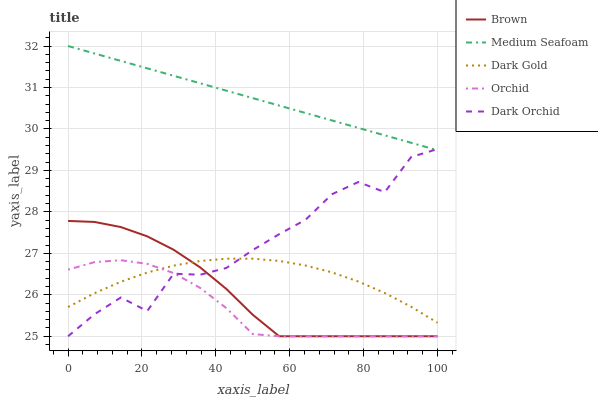Does Orchid have the minimum area under the curve?
Answer yes or no. Yes. Does Medium Seafoam have the maximum area under the curve?
Answer yes or no. Yes. Does Medium Seafoam have the minimum area under the curve?
Answer yes or no. No. Does Orchid have the maximum area under the curve?
Answer yes or no. No. Is Medium Seafoam the smoothest?
Answer yes or no. Yes. Is Dark Orchid the roughest?
Answer yes or no. Yes. Is Orchid the smoothest?
Answer yes or no. No. Is Orchid the roughest?
Answer yes or no. No. Does Brown have the lowest value?
Answer yes or no. Yes. Does Medium Seafoam have the lowest value?
Answer yes or no. No. Does Medium Seafoam have the highest value?
Answer yes or no. Yes. Does Orchid have the highest value?
Answer yes or no. No. Is Brown less than Medium Seafoam?
Answer yes or no. Yes. Is Medium Seafoam greater than Dark Gold?
Answer yes or no. Yes. Does Dark Orchid intersect Brown?
Answer yes or no. Yes. Is Dark Orchid less than Brown?
Answer yes or no. No. Is Dark Orchid greater than Brown?
Answer yes or no. No. Does Brown intersect Medium Seafoam?
Answer yes or no. No. 